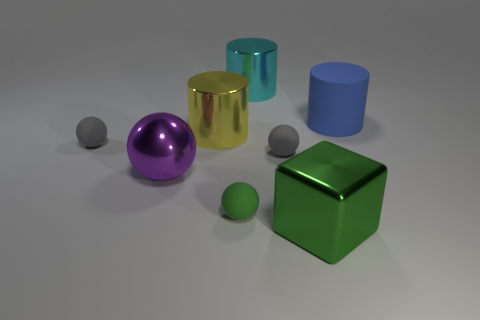There is a green sphere that is in front of the big cylinder that is behind the cylinder that is on the right side of the green metal object; what is its material?
Give a very brief answer. Rubber. There is a matte ball that is the same color as the large metal block; what is its size?
Make the answer very short. Small. What material is the large yellow thing?
Your response must be concise. Metal. Is the material of the green sphere the same as the gray thing left of the big cyan object?
Make the answer very short. Yes. What color is the rubber thing behind the small gray matte ball on the left side of the large purple sphere?
Provide a short and direct response. Blue. What is the size of the metal object that is both in front of the large yellow cylinder and to the left of the small green matte thing?
Provide a succinct answer. Large. What number of other things are there of the same shape as the large blue thing?
Give a very brief answer. 2. Does the purple metallic thing have the same shape as the metallic object behind the blue object?
Make the answer very short. No. There is a cyan shiny cylinder; how many large cyan shiny cylinders are behind it?
Your answer should be compact. 0. Is there any other thing that is made of the same material as the big blue cylinder?
Provide a succinct answer. Yes. 